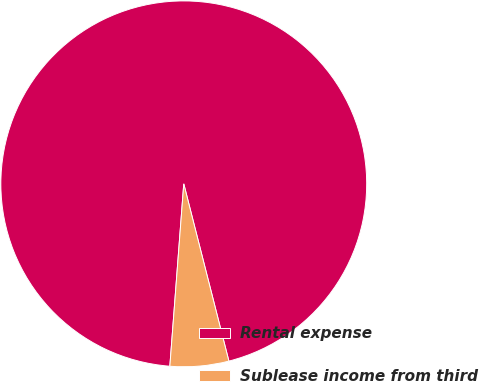Convert chart. <chart><loc_0><loc_0><loc_500><loc_500><pie_chart><fcel>Rental expense<fcel>Sublease income from third<nl><fcel>94.82%<fcel>5.18%<nl></chart> 